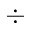<formula> <loc_0><loc_0><loc_500><loc_500>\div</formula> 